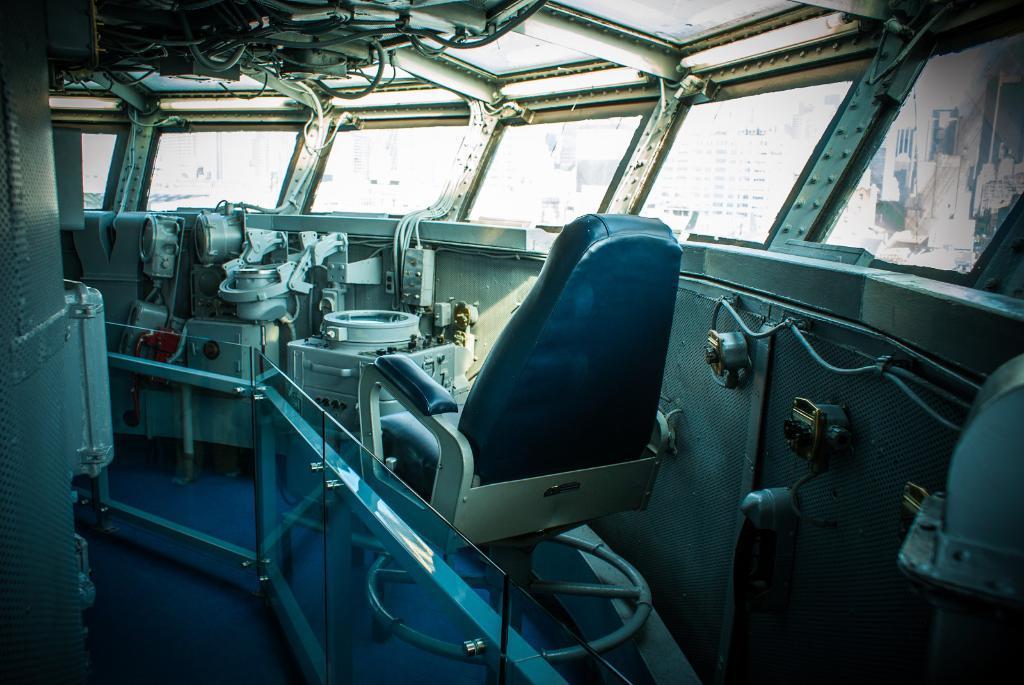Please provide a concise description of this image. In the picture we can see a machinery and beside it we can see a chair and a railing with a glass and on the other side we can see window from it we can see some buildings. 